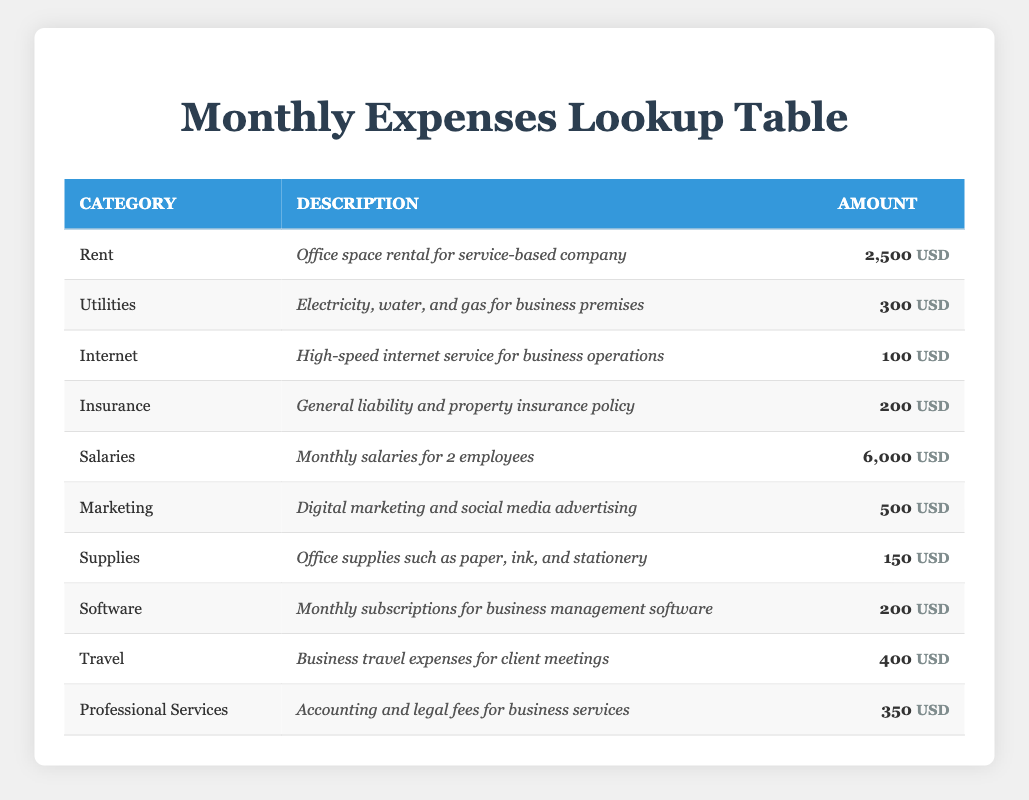What is the total amount spent on Salaries and Rent? To find the total amount spent on Salaries and Rent, we first identify the amounts in these categories from the table: Salaries amount to 6,000 USD and Rent amounts to 2,500 USD. We then add these two amounts together: 6,000 + 2,500 = 8,500.
Answer: 8,500 USD What is the monthly expense for the Internet service? According to the table, the amount listed for Internet is 100 USD.
Answer: 100 USD Is the total amount spent on Utilities and Insurance more than the amount spent on Marketing? First, we find the amounts for Utilities (300 USD) and Insurance (200 USD). We add these together: 300 + 200 = 500 USD. The amount for Marketing is 500 USD. Since 500 is not greater than 500, the answer is no.
Answer: No How much do the Professional Services and Travel expenses add up to? From the table, the amount for Professional Services is 350 USD and Travel expenses are 400 USD. We sum these amounts: 350 + 400 = 750 USD.
Answer: 750 USD What is the total expenditure on Supplies, Software, and Internet? We need to look up the amounts for Supplies (150 USD), Software (200 USD), and Internet (100 USD). We then add these amounts together: 150 + 200 + 100 = 450 USD.
Answer: 450 USD Is the amount spent on Marketing greater than the total spent on Utilities and Supplies combined? First, we identify the Marketing amount (500 USD). Next, we combine the amounts for Utilities (300 USD) and Supplies (150 USD), which totals 450 USD. Since 500 is greater than 450, we can confirm the answer is yes.
Answer: Yes What is the average monthly expense for all categories? To calculate the average, we first sum all monthly expenses: Rent (2,500) + Utilities (300) + Internet (100) + Insurance (200) + Salaries (6,000) + Marketing (500) + Supplies (150) + Software (200) + Travel (400) + Professional Services (350) = 10,800 USD. There are 10 expense categories. We divide the total by the number of categories: 10,800 / 10 = 1,080 USD.
Answer: 1,080 USD Which expense category has the highest amount? Looking through the table, Salaries amount to 6,000 USD, which is greater than any other category listed. Therefore, the highest expense category is Salaries.
Answer: Salaries How much more is spent on Rent than on Insurance? The amount spent on Rent is 2,500 USD and on Insurance it is 200 USD. We subtract the Insurance amount from the Rent amount: 2,500 - 200 = 2,300 USD.
Answer: 2,300 USD 